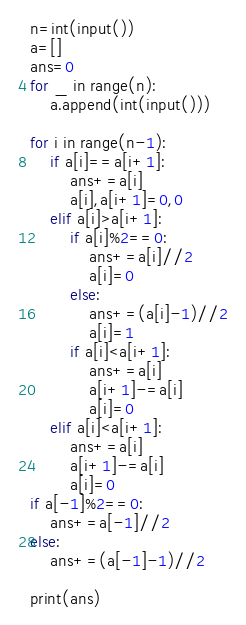Convert code to text. <code><loc_0><loc_0><loc_500><loc_500><_Python_>n=int(input())
a=[]
ans=0
for _ in range(n):
    a.append(int(input()))

for i in range(n-1):
    if a[i]==a[i+1]:
        ans+=a[i]
        a[i],a[i+1]=0,0
    elif a[i]>a[i+1]:
        if a[i]%2==0:
            ans+=a[i]//2
            a[i]=0
        else:
            ans+=(a[i]-1)//2
            a[i]=1
        if a[i]<a[i+1]:
            ans+=a[i]
            a[i+1]-=a[i]
            a[i]=0
    elif a[i]<a[i+1]:
        ans+=a[i]
        a[i+1]-=a[i]
        a[i]=0
if a[-1]%2==0:
    ans+=a[-1]//2
else:
    ans+=(a[-1]-1)//2

print(ans)</code> 